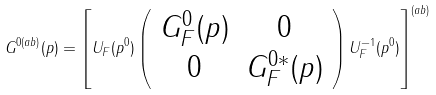Convert formula to latex. <formula><loc_0><loc_0><loc_500><loc_500>G ^ { 0 ( a b ) } ( p ) = \left [ U _ { F } ( p ^ { 0 } ) \left ( \begin{array} { c c } G ^ { 0 } _ { F } ( p ) & 0 \\ 0 & G ^ { 0 * } _ { F } ( p ) \end{array} \right ) U _ { F } ^ { - 1 } ( p ^ { 0 } ) \right ] ^ { ( a b ) }</formula> 